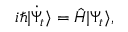Convert formula to latex. <formula><loc_0><loc_0><loc_500><loc_500>i \hbar { | } \ D o t { \Psi } _ { t } \rangle = \hat { H } | \Psi _ { t } \rangle ,</formula> 